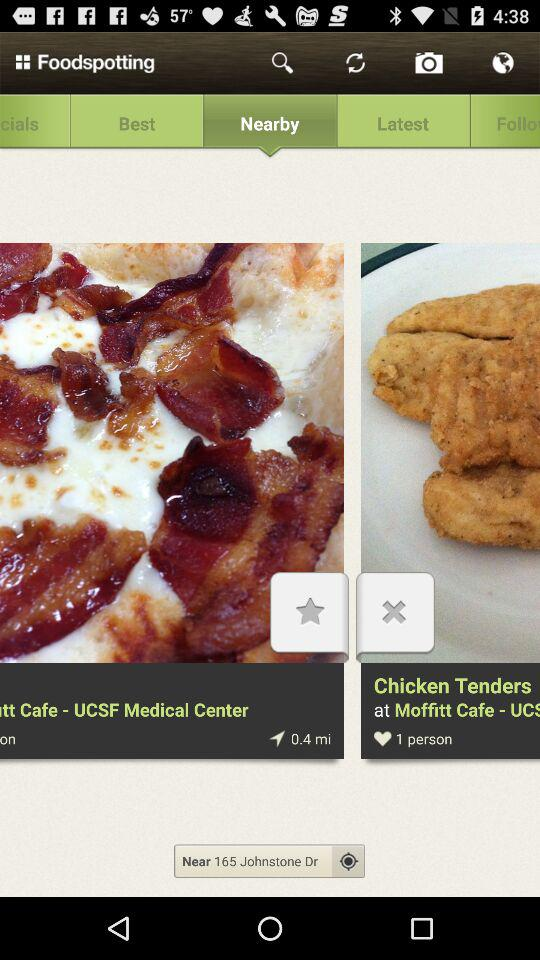What is the cuisine name? The cuisine name is Chicken Tenders. 